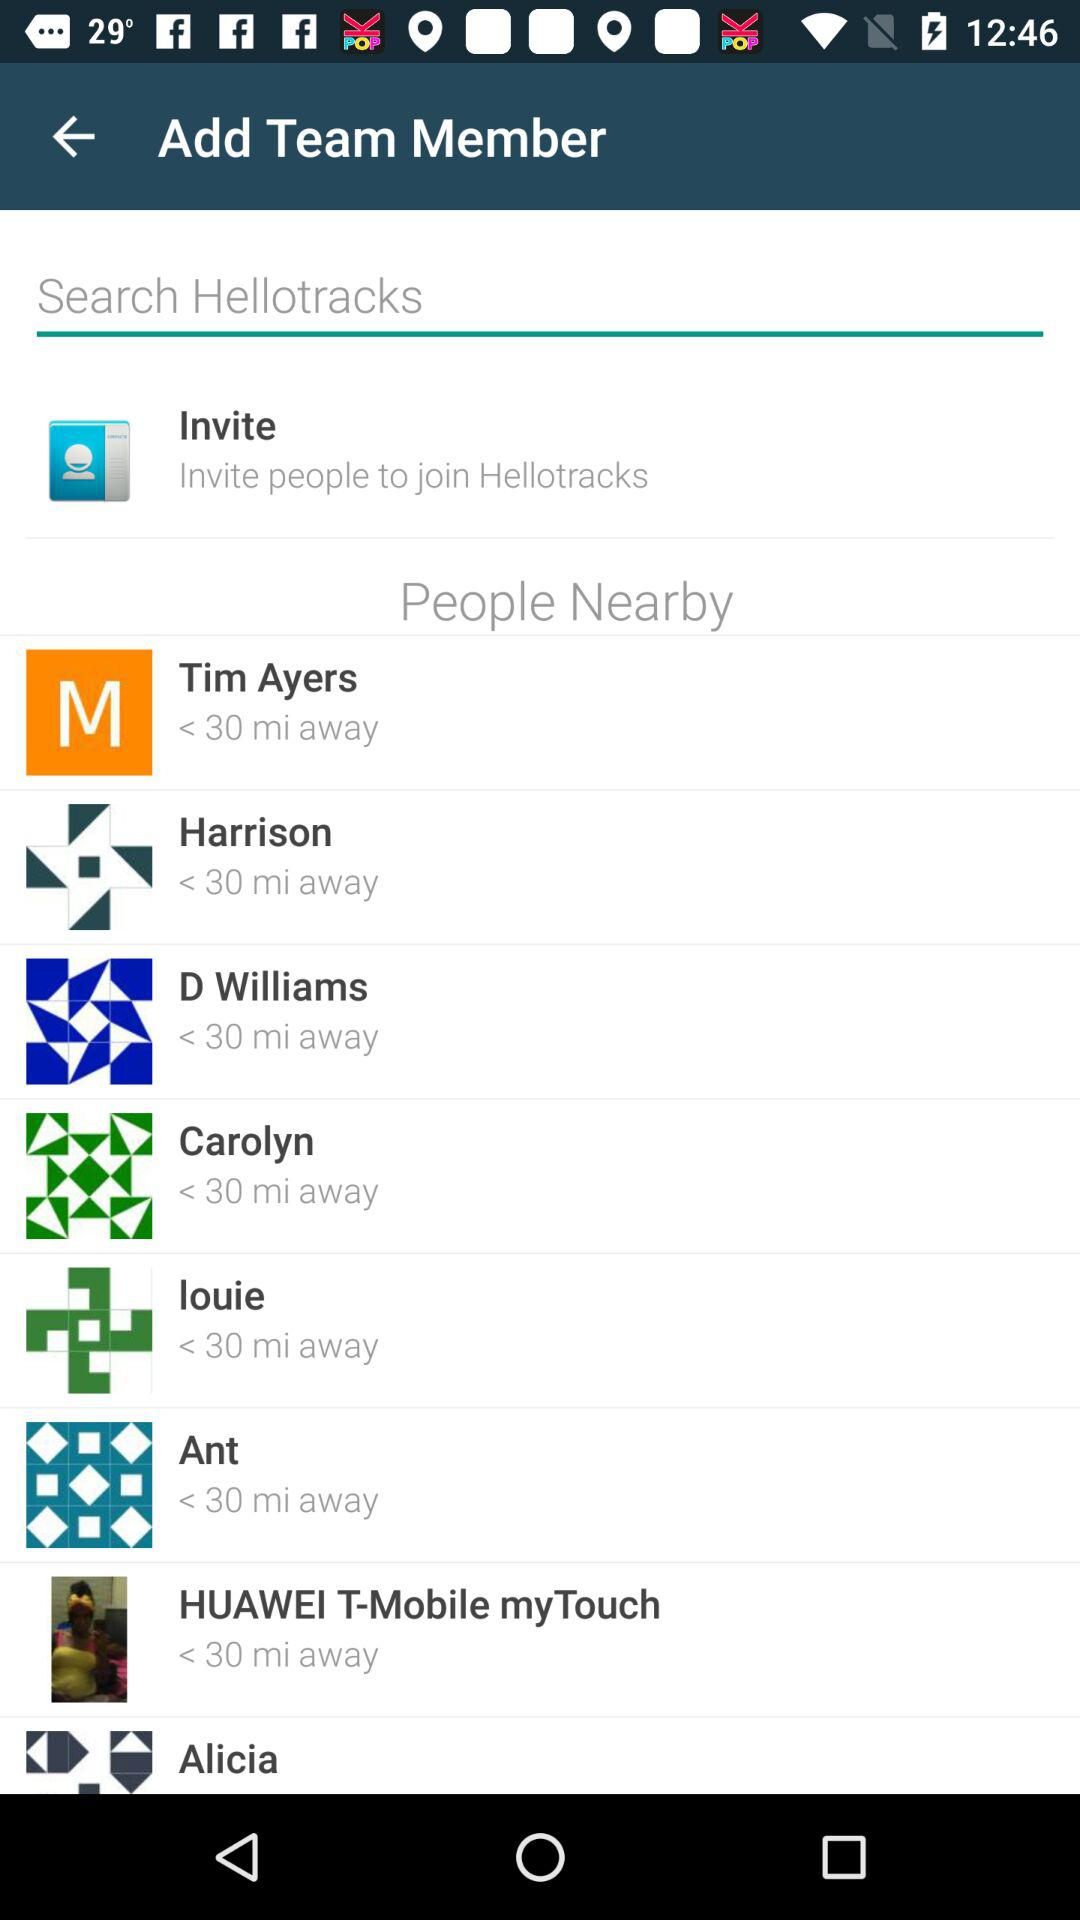How many miles away is "Tim Ayers"? "Tim Ayers" is less than 30 minutes away. 